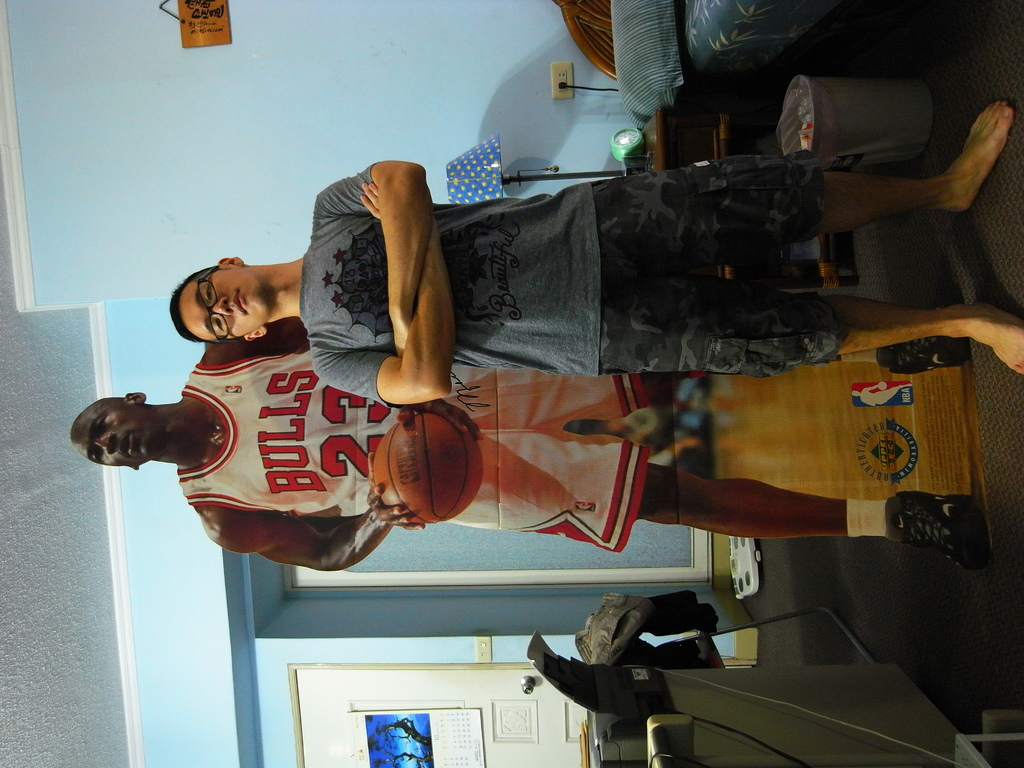Can you explain the significance of the jersey number 23 in basketball? Jersey number 23 is famously worn by Michael Jordan, one of the greatest basketball players of all time. It symbolizes excellence and greatness in the sport, often chosen by players who admire Jordan's legacy. 